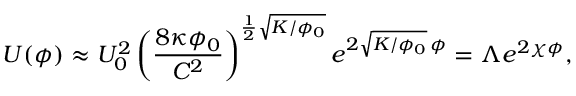<formula> <loc_0><loc_0><loc_500><loc_500>U ( \phi ) \approx U _ { 0 } ^ { 2 } \left ( \frac { 8 \kappa \phi _ { 0 } } { C ^ { 2 } } \right ) ^ { \frac { 1 } { 2 } \sqrt { K / \phi _ { 0 } } } e ^ { 2 \sqrt { K / \phi _ { 0 } } \, \phi } = \Lambda e ^ { 2 \chi \phi } ,</formula> 